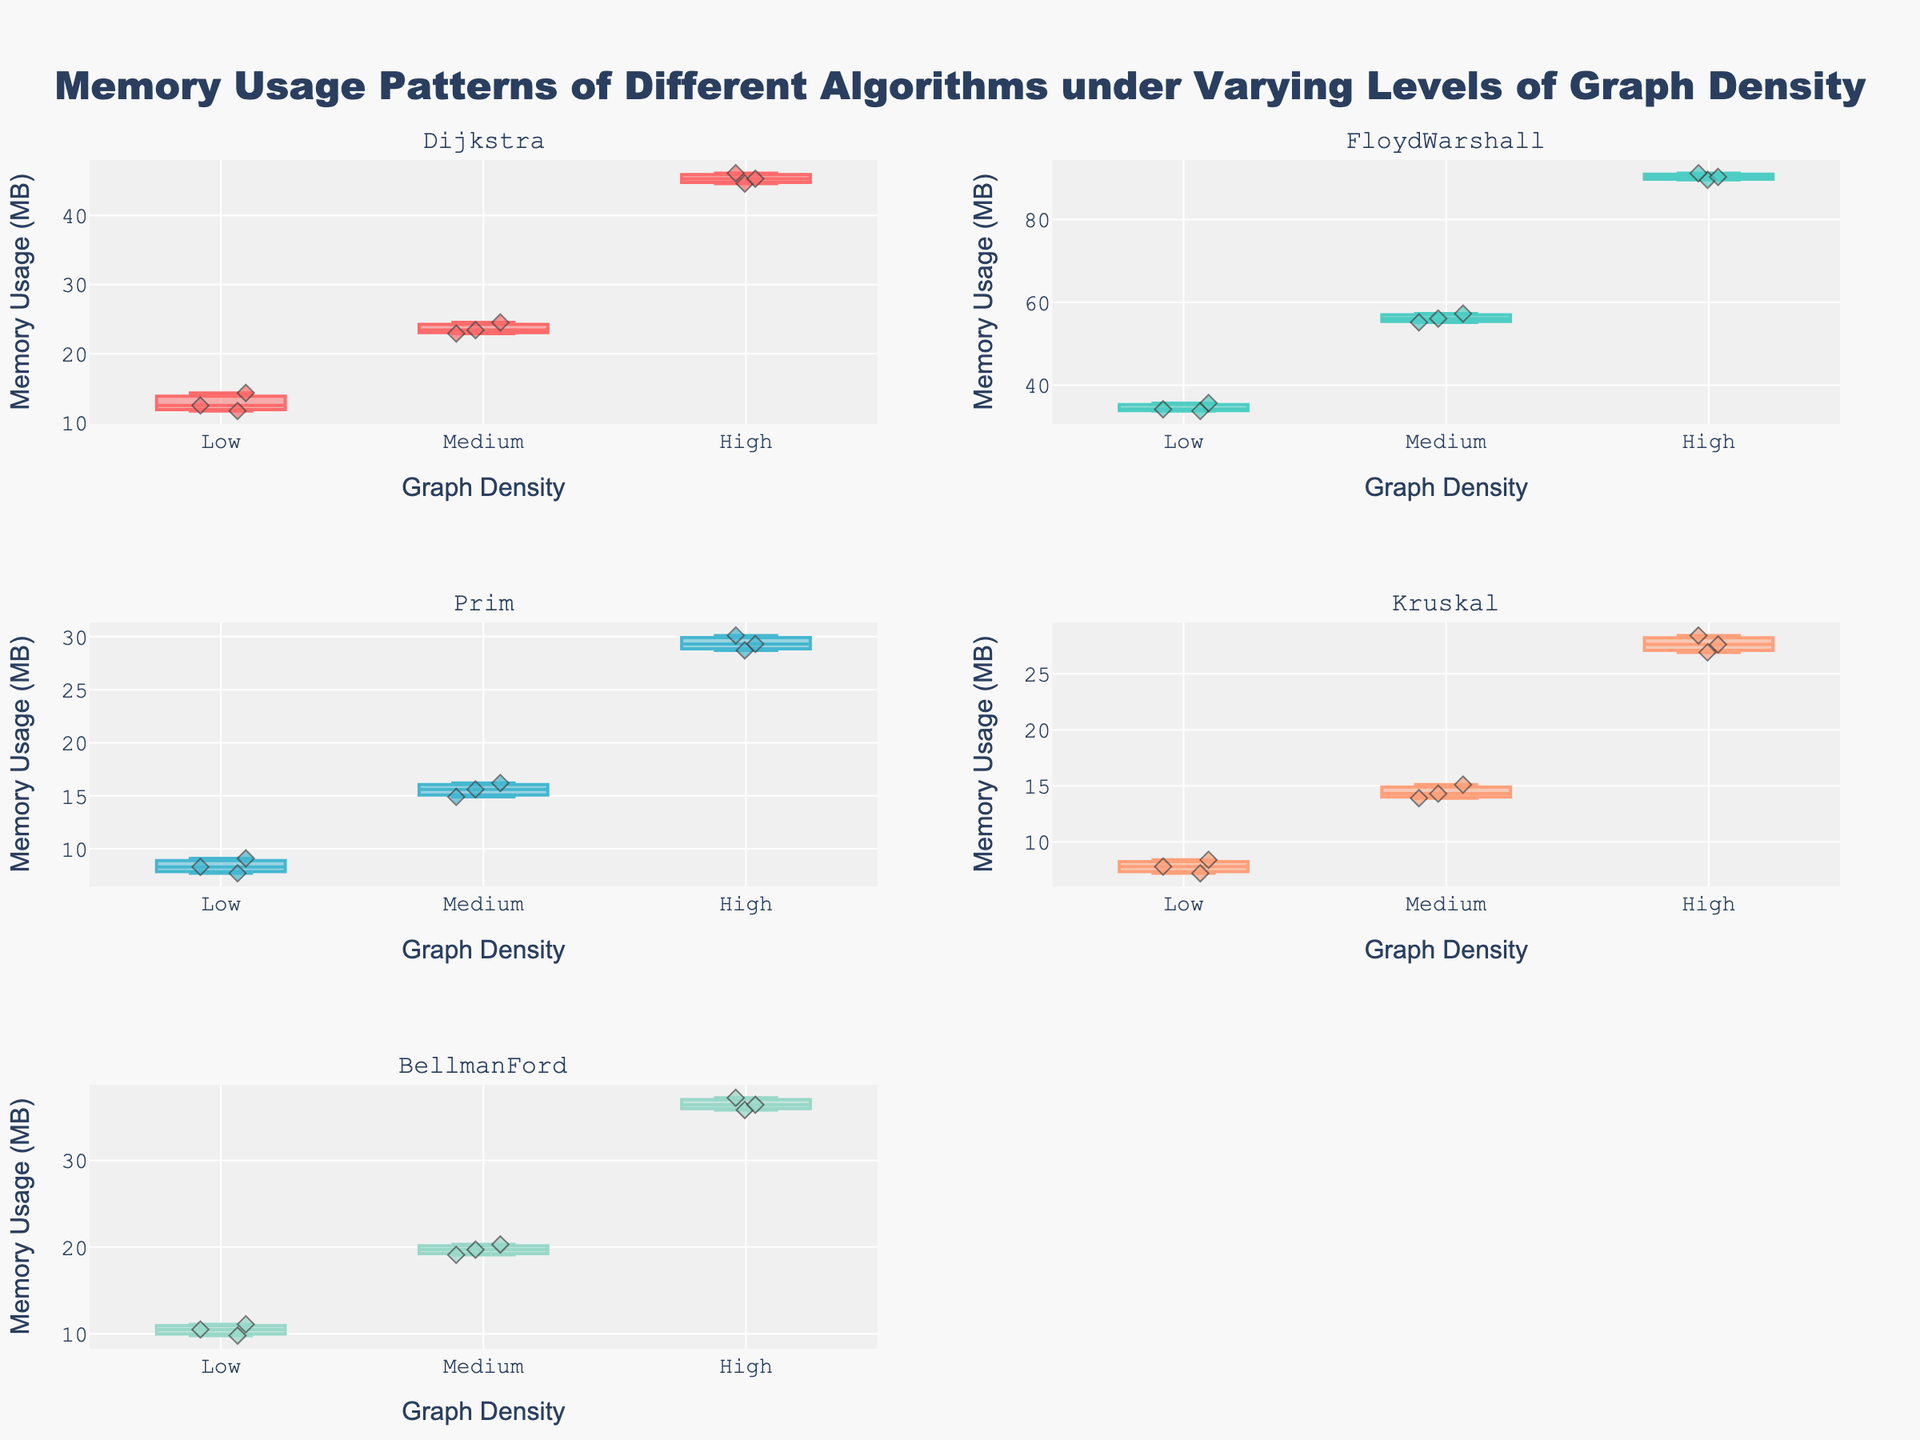How many algorithms are exhibited in the subplots? There are 5 unique subplot titles, each displaying a different algorithm. Therefore, there are 5 algorithms.
Answer: 5 What is the title of the plot? The title is displayed at the top-center of the plot.
Answer: Memory Usage Patterns of Different Algorithms under Varying Levels of Graph Density Which algorithm has the highest memory usage at high graph density? By examining the "High" graph density for each algorithm, FloydWarshall has the highest memory usage among them.
Answer: FloydWarshall What's the range of memory usage for Prim at medium graph density? For Prim at medium graph density, the lowest memory usage is 14.9 MB and the highest is 16.2 MB, so the range is 16.2-14.9.
Answer: 1.3 MB Compare the median memory usage of Dijkstra and BellmanFord at low graph density. Which is higher? The median can be estimated by locating the central value of the box for both algorithms in low density. BellmanFord's median is higher.
Answer: BellmanFord Which algorithms show an increasing trend in memory usage from low to high graph densities? By examining the trend across different densities (Low, Medium, High), it is clear that Dijkstra, FloydWarshall, Prim, Kruskal, and BellmanFord all show increasing trends.
Answer: All algorithms What is the interquartile range (IQR) for Kruskal at low density? The IQR is calculated by subtracting the first quartile from the third quartile, approximately 8.4 - 7.2.
Answer: 1.2 MB Which algorithm has the lowest memory usage at any graph density level? By comparing the lowest points in all subplots, Kruskal has the lowest memory usage at low graph density (7.2 MB).
Answer: Kruskal What is the median memory usage of FloydWarshall at high graph density? The central value of the "High" density box plot for FloydWarshall shows the median, approximately at the center between 89.6 MB and 91.2 MB. The median value is around 90.3 MB.
Answer: 90.3 MB 